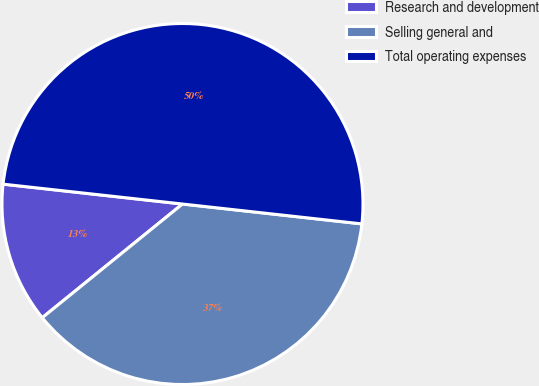<chart> <loc_0><loc_0><loc_500><loc_500><pie_chart><fcel>Research and development<fcel>Selling general and<fcel>Total operating expenses<nl><fcel>12.6%<fcel>37.4%<fcel>50.0%<nl></chart> 